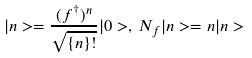Convert formula to latex. <formula><loc_0><loc_0><loc_500><loc_500>| n > = \frac { ( f ^ { \dagger } ) ^ { n } } { \sqrt { \{ n \} ! } } | 0 > , \, N _ { f } | n > = n | n ></formula> 